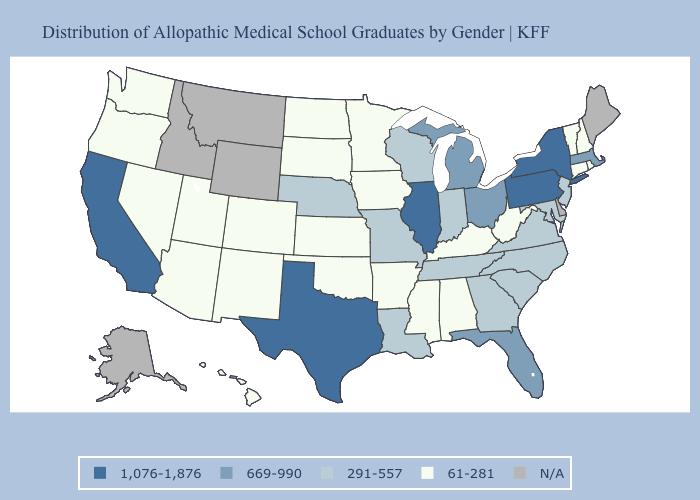What is the highest value in the USA?
Give a very brief answer. 1,076-1,876. Does Rhode Island have the lowest value in the Northeast?
Keep it brief. Yes. Which states have the highest value in the USA?
Concise answer only. California, Illinois, New York, Pennsylvania, Texas. What is the highest value in the USA?
Keep it brief. 1,076-1,876. Name the states that have a value in the range 669-990?
Be succinct. Florida, Massachusetts, Michigan, Ohio. Which states have the highest value in the USA?
Keep it brief. California, Illinois, New York, Pennsylvania, Texas. What is the lowest value in the USA?
Be succinct. 61-281. How many symbols are there in the legend?
Short answer required. 5. Name the states that have a value in the range 1,076-1,876?
Quick response, please. California, Illinois, New York, Pennsylvania, Texas. Name the states that have a value in the range N/A?
Quick response, please. Alaska, Delaware, Idaho, Maine, Montana, Wyoming. Which states have the lowest value in the USA?
Concise answer only. Alabama, Arizona, Arkansas, Colorado, Connecticut, Hawaii, Iowa, Kansas, Kentucky, Minnesota, Mississippi, Nevada, New Hampshire, New Mexico, North Dakota, Oklahoma, Oregon, Rhode Island, South Dakota, Utah, Vermont, Washington, West Virginia. What is the lowest value in the USA?
Keep it brief. 61-281. Name the states that have a value in the range N/A?
Keep it brief. Alaska, Delaware, Idaho, Maine, Montana, Wyoming. What is the lowest value in the USA?
Be succinct. 61-281. Does the first symbol in the legend represent the smallest category?
Write a very short answer. No. 